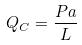<formula> <loc_0><loc_0><loc_500><loc_500>Q _ { C } = \frac { P a } { L }</formula> 